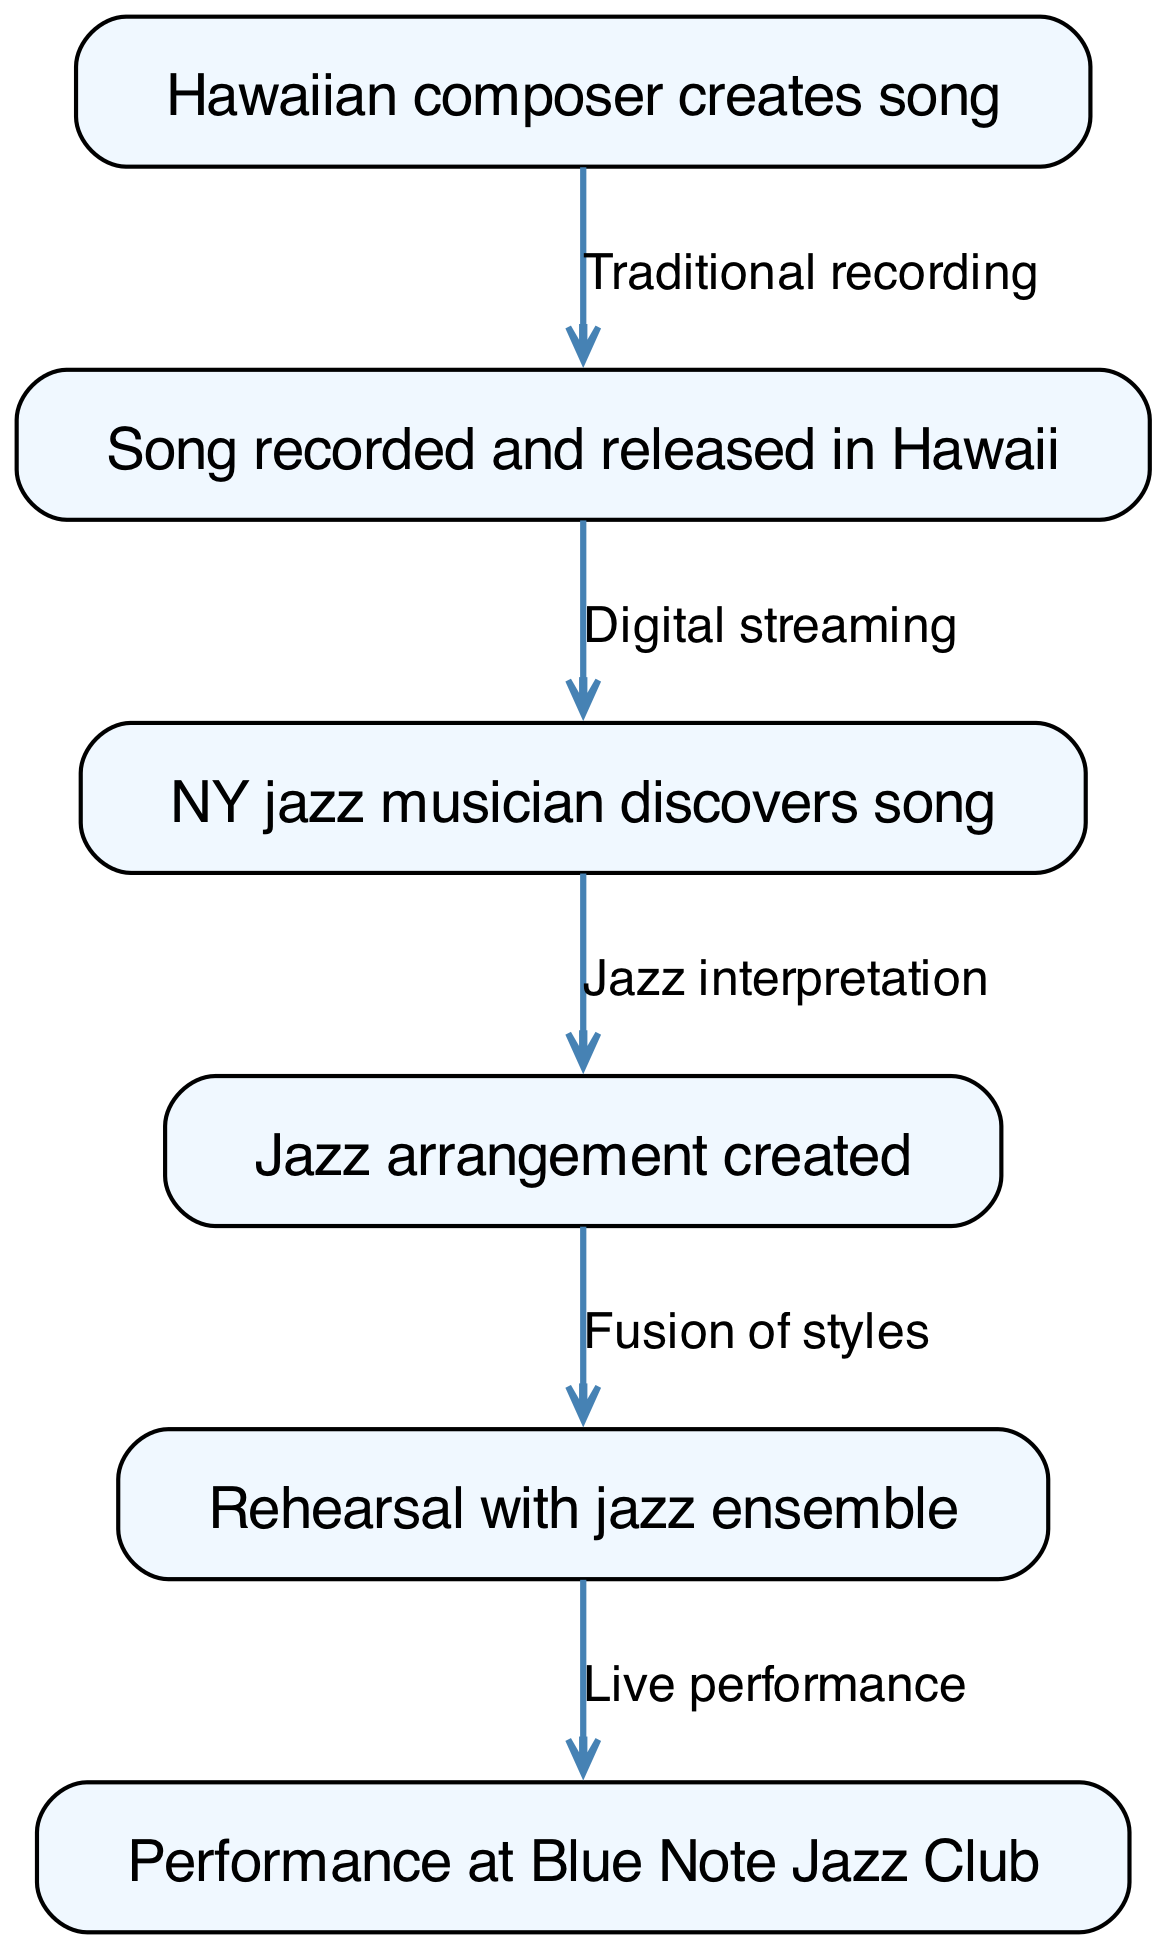What is the first step in the journey of the Hawaiian song? The first step is represented by the first node in the diagram, which indicates that the Hawaiian composer creates the song.
Answer: Hawaiian composer creates song How many nodes are present in the diagram? The diagram features a total of 6 nodes, each representing a different stage in the journey of the Hawaiian song.
Answer: 6 What does the edge from node 2 to node 3 represent? The edge indicates the method of how the song reaches the NY jazz musician, specifically through digital streaming, which is labeled on the edge connecting these nodes.
Answer: Digital streaming Which node describes the final performance location for the jazz arrangement? The final location for the performance is specified in the last node of the diagram, indicating it takes place at the Blue Note Jazz Club.
Answer: Blue Note Jazz Club What is the relationship between node 4 and node 5? The relationship between these nodes is described by the edge connecting them, which states that the transition from jazz arrangement to rehearsal involves a fusion of styles.
Answer: Fusion of styles What is required after the NY jazz musician discovers the song? After discovery, the next essential step is the creation of a jazz arrangement, as indicated by the flow from node 3 to node 4 in the diagram.
Answer: Jazz arrangement created What are the two main processes mentioned in the journey of a Hawaiian song? The processes include the traditional recording of the song in Hawaii and the subsequent jazz interpretation created by the musician in New York.
Answer: Traditional recording, jazz interpretation From composition to performance, how many key stages are involved? The journey outlined in the diagram involves five key stages from the initial composition to the final performance.
Answer: 5 